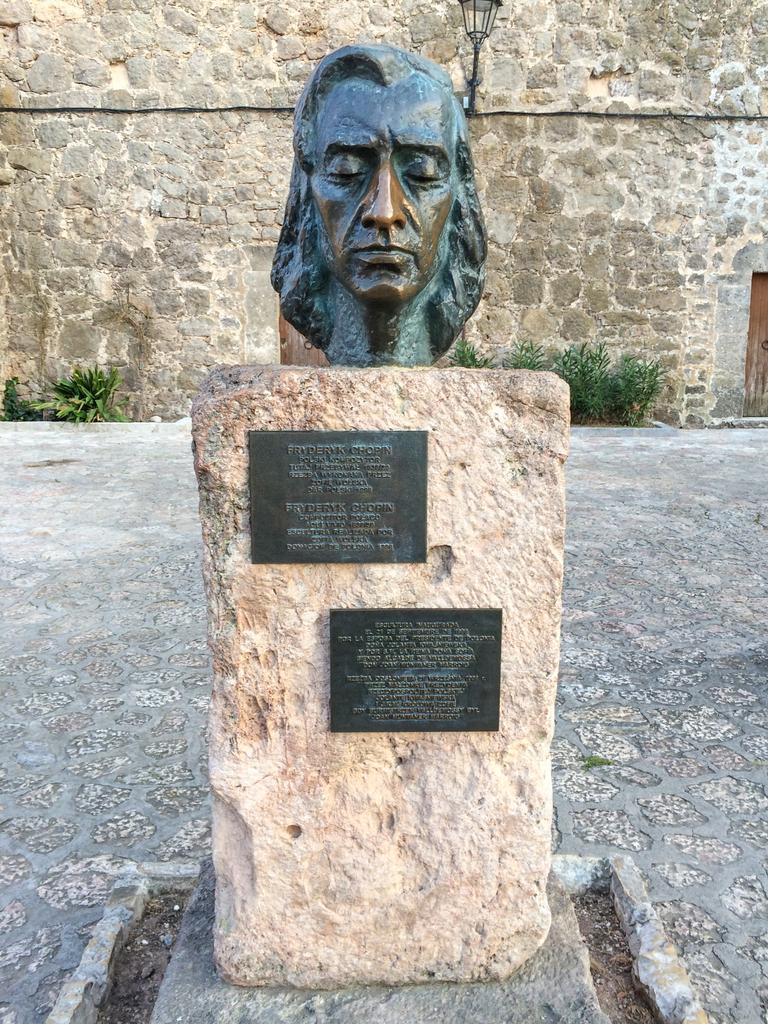Can you describe this image briefly? In the image there is a stone with black objects. On the stone there is a statue of a person. Behind the stone there is grass. And also there is a wall. On the right side of the image there is a door. 